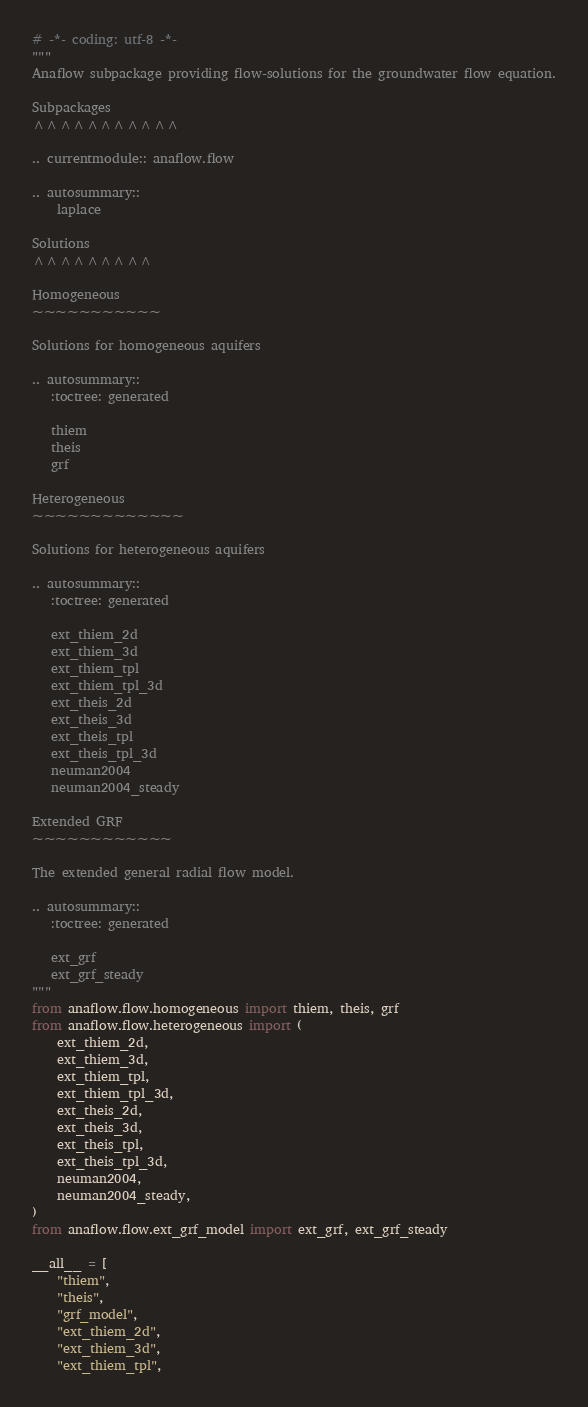<code> <loc_0><loc_0><loc_500><loc_500><_Python_># -*- coding: utf-8 -*-
"""
Anaflow subpackage providing flow-solutions for the groundwater flow equation.

Subpackages
^^^^^^^^^^^

.. currentmodule:: anaflow.flow

.. autosummary::
    laplace

Solutions
^^^^^^^^^

Homogeneous
~~~~~~~~~~~

Solutions for homogeneous aquifers

.. autosummary::
   :toctree: generated

   thiem
   theis
   grf

Heterogeneous
~~~~~~~~~~~~~

Solutions for heterogeneous aquifers

.. autosummary::
   :toctree: generated

   ext_thiem_2d
   ext_thiem_3d
   ext_thiem_tpl
   ext_thiem_tpl_3d
   ext_theis_2d
   ext_theis_3d
   ext_theis_tpl
   ext_theis_tpl_3d
   neuman2004
   neuman2004_steady

Extended GRF
~~~~~~~~~~~~

The extended general radial flow model.

.. autosummary::
   :toctree: generated

   ext_grf
   ext_grf_steady
"""
from anaflow.flow.homogeneous import thiem, theis, grf
from anaflow.flow.heterogeneous import (
    ext_thiem_2d,
    ext_thiem_3d,
    ext_thiem_tpl,
    ext_thiem_tpl_3d,
    ext_theis_2d,
    ext_theis_3d,
    ext_theis_tpl,
    ext_theis_tpl_3d,
    neuman2004,
    neuman2004_steady,
)
from anaflow.flow.ext_grf_model import ext_grf, ext_grf_steady

__all__ = [
    "thiem",
    "theis",
    "grf_model",
    "ext_thiem_2d",
    "ext_thiem_3d",
    "ext_thiem_tpl",</code> 